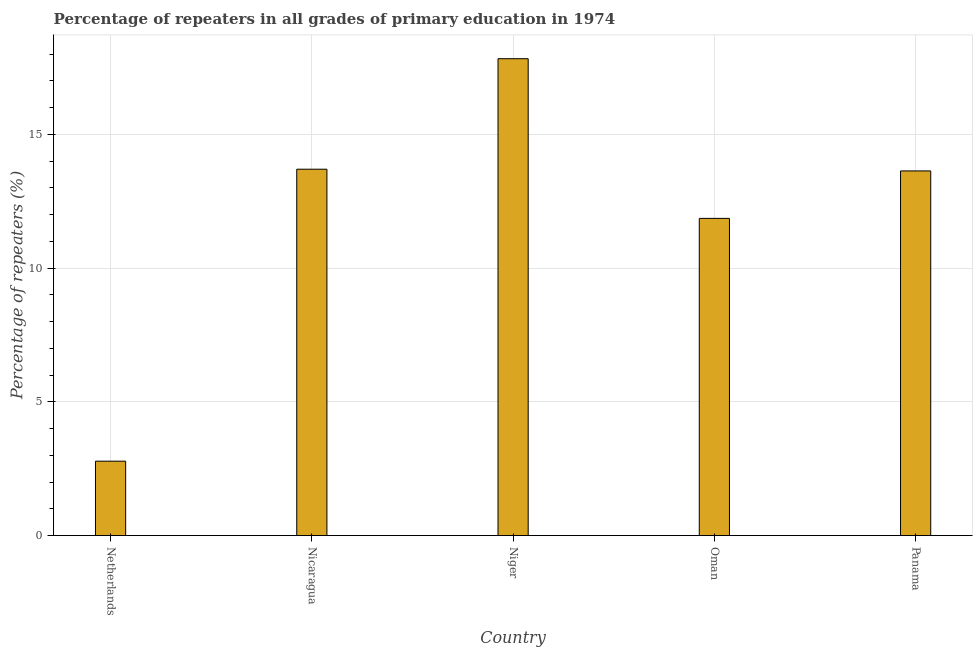Does the graph contain grids?
Make the answer very short. Yes. What is the title of the graph?
Your response must be concise. Percentage of repeaters in all grades of primary education in 1974. What is the label or title of the Y-axis?
Keep it short and to the point. Percentage of repeaters (%). What is the percentage of repeaters in primary education in Panama?
Your answer should be very brief. 13.64. Across all countries, what is the maximum percentage of repeaters in primary education?
Offer a very short reply. 17.83. Across all countries, what is the minimum percentage of repeaters in primary education?
Ensure brevity in your answer.  2.78. In which country was the percentage of repeaters in primary education maximum?
Make the answer very short. Niger. In which country was the percentage of repeaters in primary education minimum?
Make the answer very short. Netherlands. What is the sum of the percentage of repeaters in primary education?
Your response must be concise. 59.81. What is the difference between the percentage of repeaters in primary education in Nicaragua and Niger?
Your answer should be very brief. -4.13. What is the average percentage of repeaters in primary education per country?
Provide a succinct answer. 11.96. What is the median percentage of repeaters in primary education?
Make the answer very short. 13.64. What is the ratio of the percentage of repeaters in primary education in Netherlands to that in Oman?
Your response must be concise. 0.23. What is the difference between the highest and the second highest percentage of repeaters in primary education?
Provide a short and direct response. 4.13. Is the sum of the percentage of repeaters in primary education in Niger and Oman greater than the maximum percentage of repeaters in primary education across all countries?
Ensure brevity in your answer.  Yes. What is the difference between the highest and the lowest percentage of repeaters in primary education?
Provide a succinct answer. 15.05. How many bars are there?
Give a very brief answer. 5. What is the difference between two consecutive major ticks on the Y-axis?
Your answer should be very brief. 5. What is the Percentage of repeaters (%) in Netherlands?
Ensure brevity in your answer.  2.78. What is the Percentage of repeaters (%) in Nicaragua?
Ensure brevity in your answer.  13.7. What is the Percentage of repeaters (%) in Niger?
Provide a short and direct response. 17.83. What is the Percentage of repeaters (%) of Oman?
Your answer should be compact. 11.86. What is the Percentage of repeaters (%) of Panama?
Offer a very short reply. 13.64. What is the difference between the Percentage of repeaters (%) in Netherlands and Nicaragua?
Offer a terse response. -10.92. What is the difference between the Percentage of repeaters (%) in Netherlands and Niger?
Your response must be concise. -15.05. What is the difference between the Percentage of repeaters (%) in Netherlands and Oman?
Make the answer very short. -9.08. What is the difference between the Percentage of repeaters (%) in Netherlands and Panama?
Ensure brevity in your answer.  -10.85. What is the difference between the Percentage of repeaters (%) in Nicaragua and Niger?
Provide a succinct answer. -4.13. What is the difference between the Percentage of repeaters (%) in Nicaragua and Oman?
Your answer should be compact. 1.84. What is the difference between the Percentage of repeaters (%) in Nicaragua and Panama?
Offer a very short reply. 0.06. What is the difference between the Percentage of repeaters (%) in Niger and Oman?
Make the answer very short. 5.97. What is the difference between the Percentage of repeaters (%) in Niger and Panama?
Ensure brevity in your answer.  4.2. What is the difference between the Percentage of repeaters (%) in Oman and Panama?
Offer a terse response. -1.77. What is the ratio of the Percentage of repeaters (%) in Netherlands to that in Nicaragua?
Ensure brevity in your answer.  0.2. What is the ratio of the Percentage of repeaters (%) in Netherlands to that in Niger?
Offer a terse response. 0.16. What is the ratio of the Percentage of repeaters (%) in Netherlands to that in Oman?
Keep it short and to the point. 0.23. What is the ratio of the Percentage of repeaters (%) in Netherlands to that in Panama?
Keep it short and to the point. 0.2. What is the ratio of the Percentage of repeaters (%) in Nicaragua to that in Niger?
Offer a very short reply. 0.77. What is the ratio of the Percentage of repeaters (%) in Nicaragua to that in Oman?
Provide a succinct answer. 1.16. What is the ratio of the Percentage of repeaters (%) in Niger to that in Oman?
Offer a very short reply. 1.5. What is the ratio of the Percentage of repeaters (%) in Niger to that in Panama?
Provide a short and direct response. 1.31. What is the ratio of the Percentage of repeaters (%) in Oman to that in Panama?
Keep it short and to the point. 0.87. 